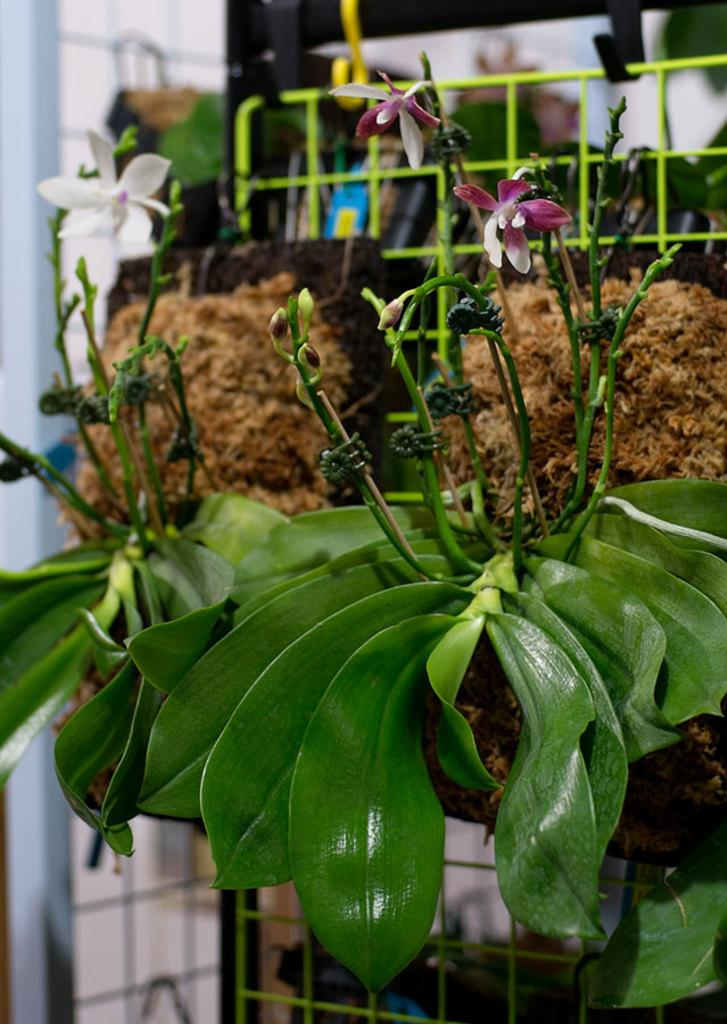What type of plants are in the image? The image contains plants with flowers. What material is the fence in the image made of? The fence in the image is made of metal. How many songs can be heard playing in the background of the image? There is no audio or music present in the image, so it is not possible to determine how many songs might be heard. 